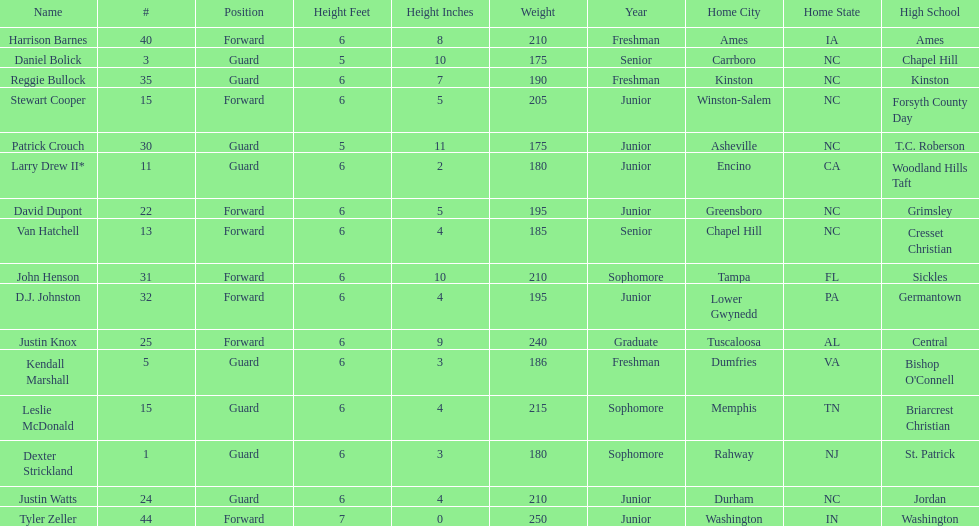What was the number of freshmen on the team? 3. 